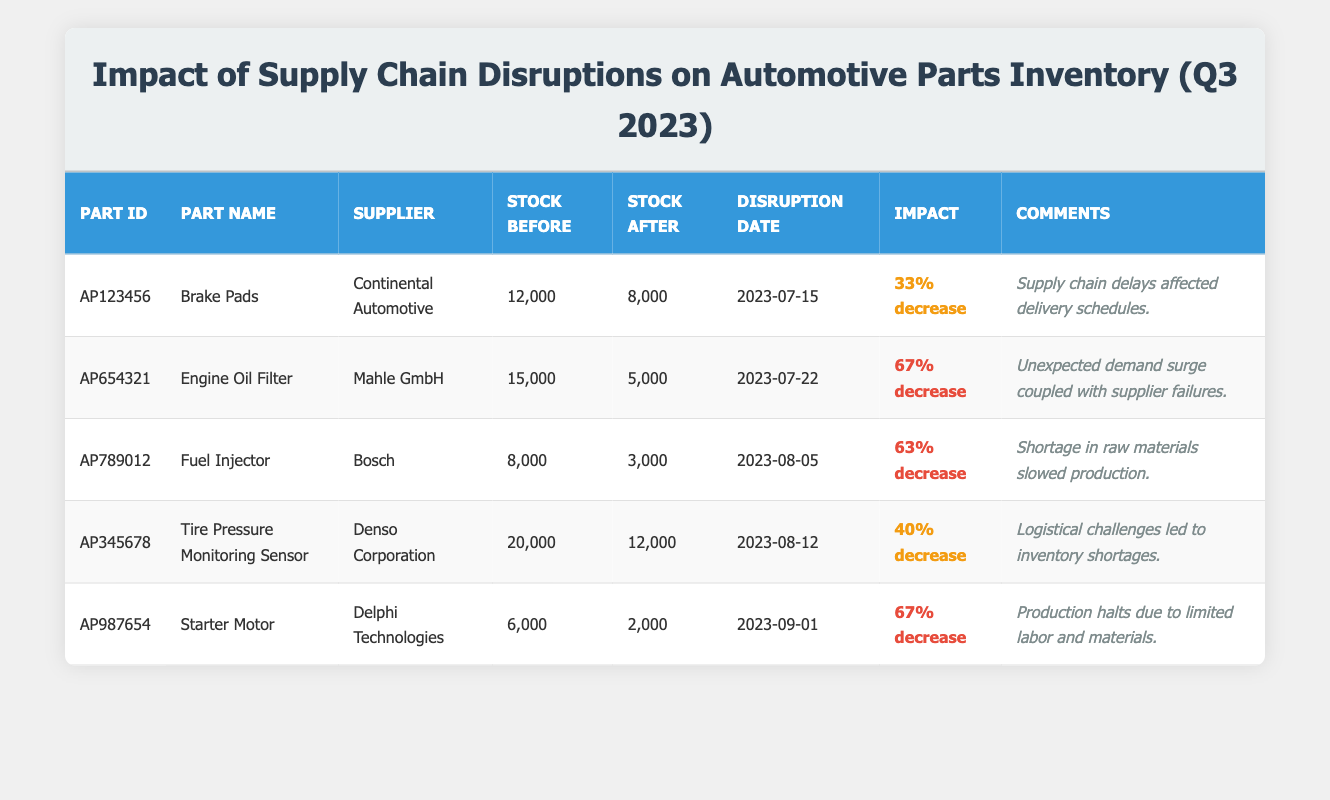What was the stock level of “Fuel Injector” before the disruption? The stock level before the disruption for the Fuel Injector (Part ID: AP789012) is listed in the table as 8000.
Answer: 8000 Which part experienced the highest percentage decrease in stock level? By comparing the "Impact" column, both Engine Oil Filter and Starter Motor show a 67% decrease, which is the highest percentage among the listed parts.
Answer: Engine Oil Filter and Starter Motor What is the total stock level decrease for all parts combined? The individual decreases are 4000 for Brake Pads, 10000 for Engine Oil Filter, 5000 for Fuel Injector, 8000 for Tire Pressure Monitoring Sensor, and 4000 for Starter Motor. Summing these gives a total decrease of 4000 + 10000 + 5000 + 8000 + 4000 = 32000.
Answer: 32000 Did any parts have an impact on inventory that was classified as low? Looking at the "Impact" column, none of the listed parts have an impact classified as low; all impacts are medium or high.
Answer: No What percentage decrease did “Tire Pressure Monitoring Sensor” experience, and how does it compare with “Brake Pads”? Tire Pressure Monitoring Sensor had a 40% decrease, while Brake Pads had a 33% decrease. Therefore, Tire Pressure Monitoring Sensor experienced a higher decrease than Brake Pads by 7%.
Answer: Tire Pressure Monitoring Sensor 40%, Brake Pads 33% How many days were there between the disruption of the Brake Pads and the Engine Oil Filter? The disruption of Brake Pads occurred on July 15, 2023, and the Engine Oil Filter on July 22, 2023. Counting the days in between gives 7 days.
Answer: 7 days What common factor contributed to the inventory disruptions for both the Fuel Injector and Starter Motor? Both Fuel Injector and Starter Motor experienced supply chain disruptions due to shortages: Fuel Injector cites shortages in raw materials and Starter Motor mentions production halts due to limited labor and materials, showing a reliance on material availability.
Answer: Shortages in supply chain factors Which supplier's part had the least stock level after the disruption? Reviewing the "Stock Level After Disruption" column, the Starter Motor (Part ID: AP987654) from Delphi Technologies had the least stock remaining with 2000.
Answer: Starter Motor 